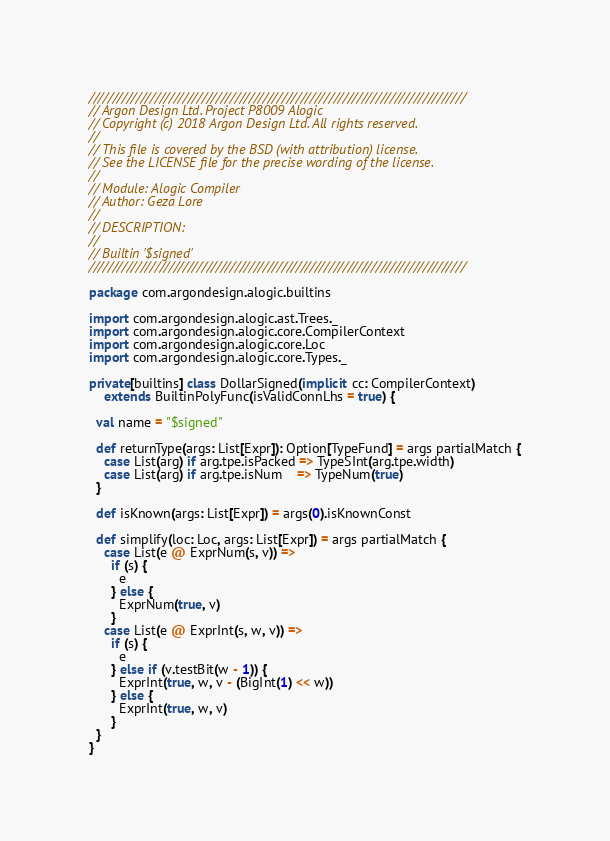<code> <loc_0><loc_0><loc_500><loc_500><_Scala_>////////////////////////////////////////////////////////////////////////////////
// Argon Design Ltd. Project P8009 Alogic
// Copyright (c) 2018 Argon Design Ltd. All rights reserved.
//
// This file is covered by the BSD (with attribution) license.
// See the LICENSE file for the precise wording of the license.
//
// Module: Alogic Compiler
// Author: Geza Lore
//
// DESCRIPTION:
//
// Builtin '$signed'
////////////////////////////////////////////////////////////////////////////////

package com.argondesign.alogic.builtins

import com.argondesign.alogic.ast.Trees._
import com.argondesign.alogic.core.CompilerContext
import com.argondesign.alogic.core.Loc
import com.argondesign.alogic.core.Types._

private[builtins] class DollarSigned(implicit cc: CompilerContext)
    extends BuiltinPolyFunc(isValidConnLhs = true) {

  val name = "$signed"

  def returnType(args: List[Expr]): Option[TypeFund] = args partialMatch {
    case List(arg) if arg.tpe.isPacked => TypeSInt(arg.tpe.width)
    case List(arg) if arg.tpe.isNum    => TypeNum(true)
  }

  def isKnown(args: List[Expr]) = args(0).isKnownConst

  def simplify(loc: Loc, args: List[Expr]) = args partialMatch {
    case List(e @ ExprNum(s, v)) =>
      if (s) {
        e
      } else {
        ExprNum(true, v)
      }
    case List(e @ ExprInt(s, w, v)) =>
      if (s) {
        e
      } else if (v.testBit(w - 1)) {
        ExprInt(true, w, v - (BigInt(1) << w))
      } else {
        ExprInt(true, w, v)
      }
  }
}
</code> 